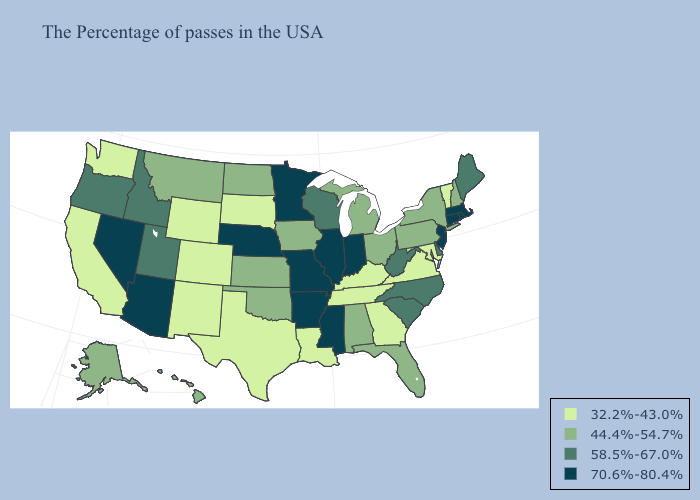Does Rhode Island have the highest value in the Northeast?
Concise answer only. Yes. Name the states that have a value in the range 58.5%-67.0%?
Keep it brief. Maine, Delaware, North Carolina, South Carolina, West Virginia, Wisconsin, Utah, Idaho, Oregon. Among the states that border Kansas , does Colorado have the highest value?
Quick response, please. No. What is the highest value in states that border Nevada?
Be succinct. 70.6%-80.4%. Among the states that border Tennessee , does Mississippi have the highest value?
Quick response, please. Yes. What is the value of Virginia?
Give a very brief answer. 32.2%-43.0%. Name the states that have a value in the range 44.4%-54.7%?
Write a very short answer. New Hampshire, New York, Pennsylvania, Ohio, Florida, Michigan, Alabama, Iowa, Kansas, Oklahoma, North Dakota, Montana, Alaska, Hawaii. Does Tennessee have the same value as Georgia?
Keep it brief. Yes. Name the states that have a value in the range 58.5%-67.0%?
Write a very short answer. Maine, Delaware, North Carolina, South Carolina, West Virginia, Wisconsin, Utah, Idaho, Oregon. What is the highest value in states that border Idaho?
Concise answer only. 70.6%-80.4%. Does Oklahoma have a higher value than Illinois?
Give a very brief answer. No. Which states have the highest value in the USA?
Answer briefly. Massachusetts, Rhode Island, Connecticut, New Jersey, Indiana, Illinois, Mississippi, Missouri, Arkansas, Minnesota, Nebraska, Arizona, Nevada. Name the states that have a value in the range 70.6%-80.4%?
Concise answer only. Massachusetts, Rhode Island, Connecticut, New Jersey, Indiana, Illinois, Mississippi, Missouri, Arkansas, Minnesota, Nebraska, Arizona, Nevada. Which states have the lowest value in the USA?
Short answer required. Vermont, Maryland, Virginia, Georgia, Kentucky, Tennessee, Louisiana, Texas, South Dakota, Wyoming, Colorado, New Mexico, California, Washington. 